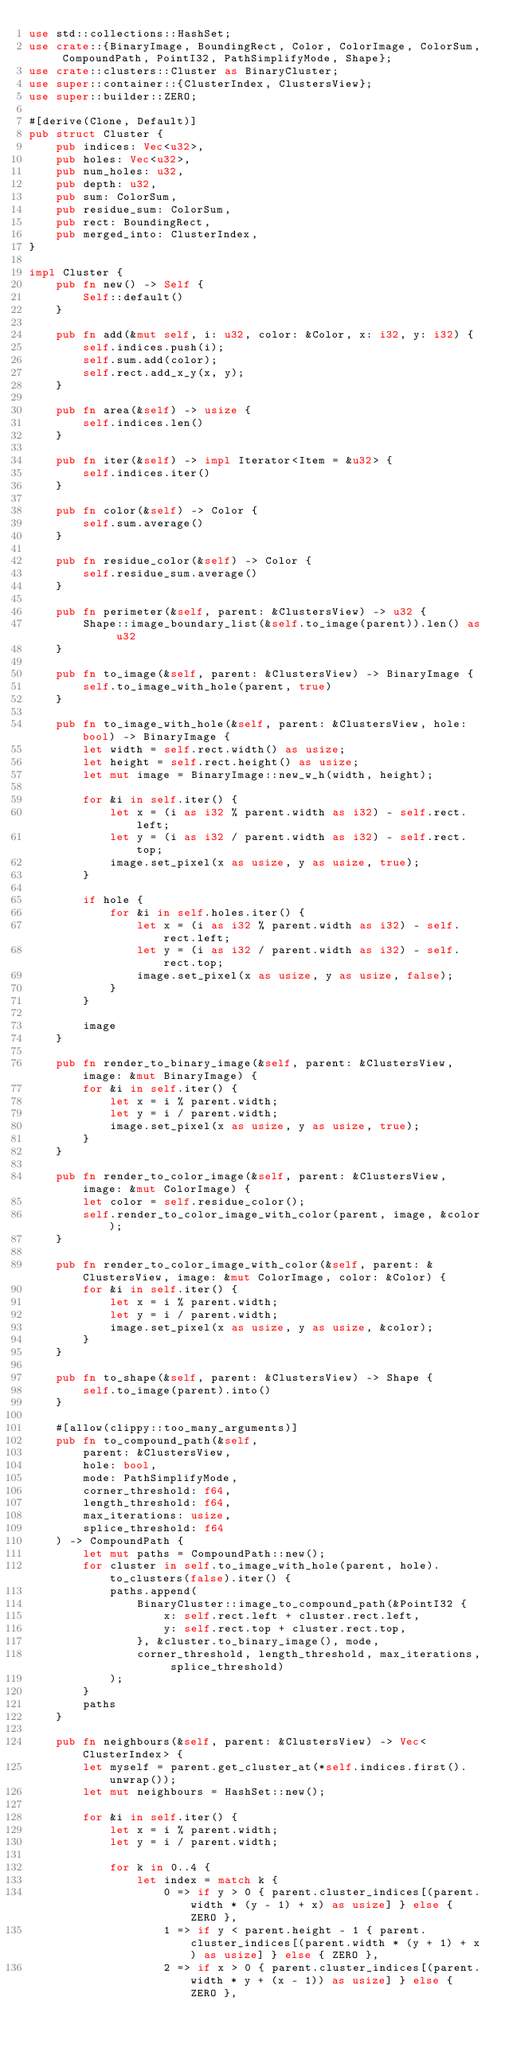<code> <loc_0><loc_0><loc_500><loc_500><_Rust_>use std::collections::HashSet;
use crate::{BinaryImage, BoundingRect, Color, ColorImage, ColorSum, CompoundPath, PointI32, PathSimplifyMode, Shape};
use crate::clusters::Cluster as BinaryCluster;
use super::container::{ClusterIndex, ClustersView};
use super::builder::ZERO;

#[derive(Clone, Default)]
pub struct Cluster {
    pub indices: Vec<u32>,
    pub holes: Vec<u32>,
    pub num_holes: u32,
    pub depth: u32,
    pub sum: ColorSum,
    pub residue_sum: ColorSum,
    pub rect: BoundingRect,
    pub merged_into: ClusterIndex,
}

impl Cluster {
    pub fn new() -> Self {
        Self::default()
    }

    pub fn add(&mut self, i: u32, color: &Color, x: i32, y: i32) {
        self.indices.push(i);
        self.sum.add(color);
        self.rect.add_x_y(x, y);
    }

    pub fn area(&self) -> usize {
        self.indices.len()
    }

    pub fn iter(&self) -> impl Iterator<Item = &u32> {
        self.indices.iter()
    }

    pub fn color(&self) -> Color {
        self.sum.average()
    }

    pub fn residue_color(&self) -> Color {
        self.residue_sum.average()
    }

    pub fn perimeter(&self, parent: &ClustersView) -> u32 {
        Shape::image_boundary_list(&self.to_image(parent)).len() as u32
    }

    pub fn to_image(&self, parent: &ClustersView) -> BinaryImage {
        self.to_image_with_hole(parent, true)
    }

    pub fn to_image_with_hole(&self, parent: &ClustersView, hole: bool) -> BinaryImage {
        let width = self.rect.width() as usize;
        let height = self.rect.height() as usize;
        let mut image = BinaryImage::new_w_h(width, height);

        for &i in self.iter() {
            let x = (i as i32 % parent.width as i32) - self.rect.left;
            let y = (i as i32 / parent.width as i32) - self.rect.top;
            image.set_pixel(x as usize, y as usize, true);
        }

        if hole {
            for &i in self.holes.iter() {
                let x = (i as i32 % parent.width as i32) - self.rect.left;
                let y = (i as i32 / parent.width as i32) - self.rect.top;
                image.set_pixel(x as usize, y as usize, false);
            }
        }

        image
    }

    pub fn render_to_binary_image(&self, parent: &ClustersView, image: &mut BinaryImage) {
        for &i in self.iter() {
            let x = i % parent.width;
            let y = i / parent.width;
            image.set_pixel(x as usize, y as usize, true);
        }
    }

    pub fn render_to_color_image(&self, parent: &ClustersView, image: &mut ColorImage) {
        let color = self.residue_color();
        self.render_to_color_image_with_color(parent, image, &color);
    }

    pub fn render_to_color_image_with_color(&self, parent: &ClustersView, image: &mut ColorImage, color: &Color) {
        for &i in self.iter() {
            let x = i % parent.width;
            let y = i / parent.width;
            image.set_pixel(x as usize, y as usize, &color);
        }
    }

    pub fn to_shape(&self, parent: &ClustersView) -> Shape {
        self.to_image(parent).into()
    }

    #[allow(clippy::too_many_arguments)]
    pub fn to_compound_path(&self,
        parent: &ClustersView,
        hole: bool,
        mode: PathSimplifyMode,
        corner_threshold: f64,
        length_threshold: f64,
        max_iterations: usize,
        splice_threshold: f64
    ) -> CompoundPath {
        let mut paths = CompoundPath::new();
        for cluster in self.to_image_with_hole(parent, hole).to_clusters(false).iter() {
            paths.append(
                BinaryCluster::image_to_compound_path(&PointI32 {
                    x: self.rect.left + cluster.rect.left,
                    y: self.rect.top + cluster.rect.top,
                }, &cluster.to_binary_image(), mode,
                corner_threshold, length_threshold, max_iterations, splice_threshold)
            );
        }
        paths
    }

    pub fn neighbours(&self, parent: &ClustersView) -> Vec<ClusterIndex> {
        let myself = parent.get_cluster_at(*self.indices.first().unwrap());
        let mut neighbours = HashSet::new();

        for &i in self.iter() {
            let x = i % parent.width;
            let y = i / parent.width;

            for k in 0..4 {
                let index = match k {
                    0 => if y > 0 { parent.cluster_indices[(parent.width * (y - 1) + x) as usize] } else { ZERO },
                    1 => if y < parent.height - 1 { parent.cluster_indices[(parent.width * (y + 1) + x) as usize] } else { ZERO },
                    2 => if x > 0 { parent.cluster_indices[(parent.width * y + (x - 1)) as usize] } else { ZERO },</code> 